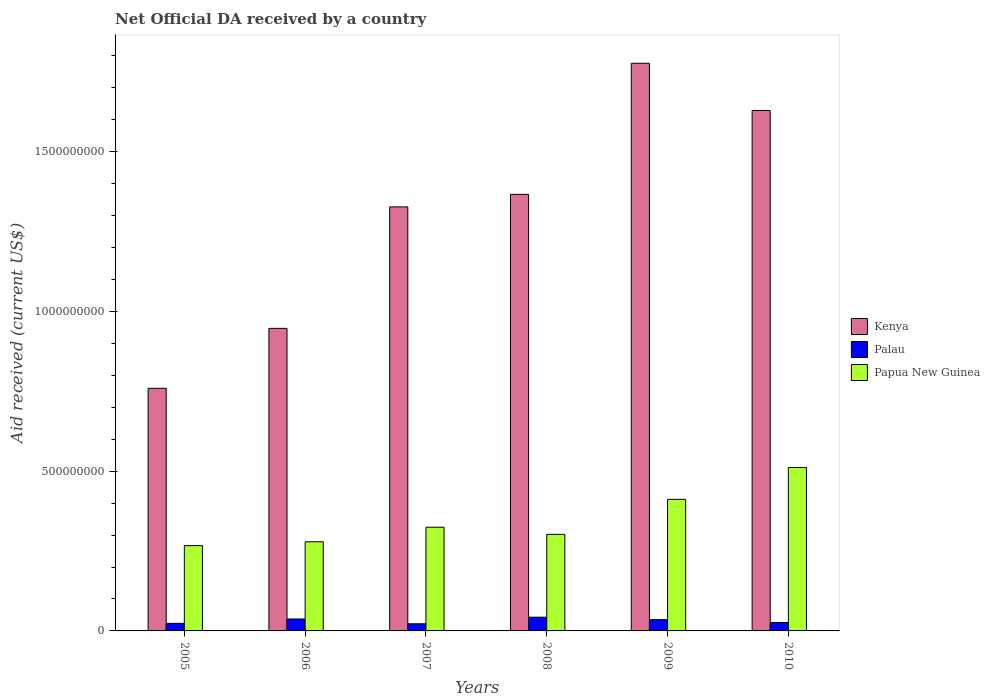How many groups of bars are there?
Provide a succinct answer. 6. Are the number of bars per tick equal to the number of legend labels?
Offer a very short reply. Yes. Are the number of bars on each tick of the X-axis equal?
Make the answer very short. Yes. How many bars are there on the 1st tick from the left?
Keep it short and to the point. 3. What is the net official development assistance aid received in Kenya in 2006?
Ensure brevity in your answer.  9.47e+08. Across all years, what is the maximum net official development assistance aid received in Kenya?
Offer a very short reply. 1.78e+09. Across all years, what is the minimum net official development assistance aid received in Papua New Guinea?
Provide a short and direct response. 2.67e+08. In which year was the net official development assistance aid received in Palau maximum?
Provide a short and direct response. 2008. What is the total net official development assistance aid received in Papua New Guinea in the graph?
Your response must be concise. 2.10e+09. What is the difference between the net official development assistance aid received in Palau in 2005 and that in 2009?
Provide a short and direct response. -1.17e+07. What is the difference between the net official development assistance aid received in Kenya in 2008 and the net official development assistance aid received in Papua New Guinea in 2005?
Provide a short and direct response. 1.10e+09. What is the average net official development assistance aid received in Palau per year?
Keep it short and to the point. 3.13e+07. In the year 2007, what is the difference between the net official development assistance aid received in Kenya and net official development assistance aid received in Palau?
Your answer should be very brief. 1.30e+09. What is the ratio of the net official development assistance aid received in Papua New Guinea in 2007 to that in 2010?
Your answer should be compact. 0.63. Is the net official development assistance aid received in Palau in 2007 less than that in 2010?
Provide a succinct answer. Yes. What is the difference between the highest and the second highest net official development assistance aid received in Palau?
Your answer should be very brief. 5.62e+06. What is the difference between the highest and the lowest net official development assistance aid received in Kenya?
Ensure brevity in your answer.  1.02e+09. In how many years, is the net official development assistance aid received in Kenya greater than the average net official development assistance aid received in Kenya taken over all years?
Ensure brevity in your answer.  4. What does the 2nd bar from the left in 2009 represents?
Ensure brevity in your answer.  Palau. What does the 3rd bar from the right in 2005 represents?
Offer a very short reply. Kenya. Is it the case that in every year, the sum of the net official development assistance aid received in Palau and net official development assistance aid received in Papua New Guinea is greater than the net official development assistance aid received in Kenya?
Your response must be concise. No. How many years are there in the graph?
Offer a terse response. 6. What is the difference between two consecutive major ticks on the Y-axis?
Your response must be concise. 5.00e+08. Are the values on the major ticks of Y-axis written in scientific E-notation?
Make the answer very short. No. Does the graph contain any zero values?
Your answer should be compact. No. Does the graph contain grids?
Offer a terse response. No. Where does the legend appear in the graph?
Offer a very short reply. Center right. How many legend labels are there?
Offer a terse response. 3. What is the title of the graph?
Provide a succinct answer. Net Official DA received by a country. What is the label or title of the X-axis?
Your response must be concise. Years. What is the label or title of the Y-axis?
Make the answer very short. Aid received (current US$). What is the Aid received (current US$) in Kenya in 2005?
Provide a succinct answer. 7.59e+08. What is the Aid received (current US$) of Palau in 2005?
Offer a terse response. 2.37e+07. What is the Aid received (current US$) in Papua New Guinea in 2005?
Offer a terse response. 2.67e+08. What is the Aid received (current US$) in Kenya in 2006?
Your answer should be compact. 9.47e+08. What is the Aid received (current US$) of Palau in 2006?
Ensure brevity in your answer.  3.73e+07. What is the Aid received (current US$) of Papua New Guinea in 2006?
Ensure brevity in your answer.  2.79e+08. What is the Aid received (current US$) in Kenya in 2007?
Make the answer very short. 1.33e+09. What is the Aid received (current US$) of Palau in 2007?
Your answer should be very brief. 2.23e+07. What is the Aid received (current US$) of Papua New Guinea in 2007?
Your answer should be compact. 3.24e+08. What is the Aid received (current US$) in Kenya in 2008?
Ensure brevity in your answer.  1.37e+09. What is the Aid received (current US$) in Palau in 2008?
Your answer should be very brief. 4.29e+07. What is the Aid received (current US$) of Papua New Guinea in 2008?
Your response must be concise. 3.02e+08. What is the Aid received (current US$) of Kenya in 2009?
Make the answer very short. 1.78e+09. What is the Aid received (current US$) in Palau in 2009?
Your answer should be compact. 3.54e+07. What is the Aid received (current US$) in Papua New Guinea in 2009?
Keep it short and to the point. 4.12e+08. What is the Aid received (current US$) of Kenya in 2010?
Your answer should be compact. 1.63e+09. What is the Aid received (current US$) in Palau in 2010?
Offer a very short reply. 2.63e+07. What is the Aid received (current US$) in Papua New Guinea in 2010?
Offer a very short reply. 5.11e+08. Across all years, what is the maximum Aid received (current US$) of Kenya?
Give a very brief answer. 1.78e+09. Across all years, what is the maximum Aid received (current US$) of Palau?
Give a very brief answer. 4.29e+07. Across all years, what is the maximum Aid received (current US$) of Papua New Guinea?
Keep it short and to the point. 5.11e+08. Across all years, what is the minimum Aid received (current US$) in Kenya?
Your response must be concise. 7.59e+08. Across all years, what is the minimum Aid received (current US$) in Palau?
Your response must be concise. 2.23e+07. Across all years, what is the minimum Aid received (current US$) in Papua New Guinea?
Provide a succinct answer. 2.67e+08. What is the total Aid received (current US$) in Kenya in the graph?
Offer a very short reply. 7.80e+09. What is the total Aid received (current US$) of Palau in the graph?
Ensure brevity in your answer.  1.88e+08. What is the total Aid received (current US$) in Papua New Guinea in the graph?
Give a very brief answer. 2.10e+09. What is the difference between the Aid received (current US$) in Kenya in 2005 and that in 2006?
Provide a succinct answer. -1.88e+08. What is the difference between the Aid received (current US$) of Palau in 2005 and that in 2006?
Give a very brief answer. -1.36e+07. What is the difference between the Aid received (current US$) in Papua New Guinea in 2005 and that in 2006?
Your answer should be very brief. -1.20e+07. What is the difference between the Aid received (current US$) in Kenya in 2005 and that in 2007?
Offer a very short reply. -5.68e+08. What is the difference between the Aid received (current US$) of Palau in 2005 and that in 2007?
Provide a short and direct response. 1.35e+06. What is the difference between the Aid received (current US$) in Papua New Guinea in 2005 and that in 2007?
Give a very brief answer. -5.75e+07. What is the difference between the Aid received (current US$) of Kenya in 2005 and that in 2008?
Offer a terse response. -6.07e+08. What is the difference between the Aid received (current US$) of Palau in 2005 and that in 2008?
Your answer should be very brief. -1.92e+07. What is the difference between the Aid received (current US$) of Papua New Guinea in 2005 and that in 2008?
Make the answer very short. -3.52e+07. What is the difference between the Aid received (current US$) in Kenya in 2005 and that in 2009?
Keep it short and to the point. -1.02e+09. What is the difference between the Aid received (current US$) of Palau in 2005 and that in 2009?
Offer a very short reply. -1.17e+07. What is the difference between the Aid received (current US$) in Papua New Guinea in 2005 and that in 2009?
Provide a short and direct response. -1.45e+08. What is the difference between the Aid received (current US$) in Kenya in 2005 and that in 2010?
Offer a terse response. -8.69e+08. What is the difference between the Aid received (current US$) in Palau in 2005 and that in 2010?
Your response must be concise. -2.62e+06. What is the difference between the Aid received (current US$) of Papua New Guinea in 2005 and that in 2010?
Your response must be concise. -2.44e+08. What is the difference between the Aid received (current US$) in Kenya in 2006 and that in 2007?
Ensure brevity in your answer.  -3.80e+08. What is the difference between the Aid received (current US$) in Palau in 2006 and that in 2007?
Offer a very short reply. 1.50e+07. What is the difference between the Aid received (current US$) of Papua New Guinea in 2006 and that in 2007?
Give a very brief answer. -4.56e+07. What is the difference between the Aid received (current US$) of Kenya in 2006 and that in 2008?
Your answer should be very brief. -4.19e+08. What is the difference between the Aid received (current US$) in Palau in 2006 and that in 2008?
Your answer should be very brief. -5.62e+06. What is the difference between the Aid received (current US$) in Papua New Guinea in 2006 and that in 2008?
Keep it short and to the point. -2.32e+07. What is the difference between the Aid received (current US$) in Kenya in 2006 and that in 2009?
Your answer should be compact. -8.30e+08. What is the difference between the Aid received (current US$) of Palau in 2006 and that in 2009?
Provide a short and direct response. 1.97e+06. What is the difference between the Aid received (current US$) in Papua New Guinea in 2006 and that in 2009?
Ensure brevity in your answer.  -1.33e+08. What is the difference between the Aid received (current US$) in Kenya in 2006 and that in 2010?
Provide a succinct answer. -6.82e+08. What is the difference between the Aid received (current US$) of Palau in 2006 and that in 2010?
Your answer should be very brief. 1.10e+07. What is the difference between the Aid received (current US$) of Papua New Guinea in 2006 and that in 2010?
Give a very brief answer. -2.33e+08. What is the difference between the Aid received (current US$) of Kenya in 2007 and that in 2008?
Your answer should be very brief. -3.92e+07. What is the difference between the Aid received (current US$) in Palau in 2007 and that in 2008?
Offer a very short reply. -2.06e+07. What is the difference between the Aid received (current US$) in Papua New Guinea in 2007 and that in 2008?
Make the answer very short. 2.23e+07. What is the difference between the Aid received (current US$) in Kenya in 2007 and that in 2009?
Your response must be concise. -4.49e+08. What is the difference between the Aid received (current US$) of Palau in 2007 and that in 2009?
Your response must be concise. -1.30e+07. What is the difference between the Aid received (current US$) in Papua New Guinea in 2007 and that in 2009?
Your answer should be very brief. -8.72e+07. What is the difference between the Aid received (current US$) in Kenya in 2007 and that in 2010?
Provide a succinct answer. -3.02e+08. What is the difference between the Aid received (current US$) in Palau in 2007 and that in 2010?
Offer a very short reply. -3.97e+06. What is the difference between the Aid received (current US$) in Papua New Guinea in 2007 and that in 2010?
Provide a short and direct response. -1.87e+08. What is the difference between the Aid received (current US$) of Kenya in 2008 and that in 2009?
Your response must be concise. -4.10e+08. What is the difference between the Aid received (current US$) of Palau in 2008 and that in 2009?
Provide a succinct answer. 7.59e+06. What is the difference between the Aid received (current US$) of Papua New Guinea in 2008 and that in 2009?
Ensure brevity in your answer.  -1.10e+08. What is the difference between the Aid received (current US$) in Kenya in 2008 and that in 2010?
Make the answer very short. -2.63e+08. What is the difference between the Aid received (current US$) in Palau in 2008 and that in 2010?
Give a very brief answer. 1.66e+07. What is the difference between the Aid received (current US$) of Papua New Guinea in 2008 and that in 2010?
Keep it short and to the point. -2.09e+08. What is the difference between the Aid received (current US$) of Kenya in 2009 and that in 2010?
Your answer should be compact. 1.48e+08. What is the difference between the Aid received (current US$) in Palau in 2009 and that in 2010?
Give a very brief answer. 9.04e+06. What is the difference between the Aid received (current US$) in Papua New Guinea in 2009 and that in 2010?
Make the answer very short. -9.97e+07. What is the difference between the Aid received (current US$) of Kenya in 2005 and the Aid received (current US$) of Palau in 2006?
Offer a terse response. 7.22e+08. What is the difference between the Aid received (current US$) in Kenya in 2005 and the Aid received (current US$) in Papua New Guinea in 2006?
Ensure brevity in your answer.  4.80e+08. What is the difference between the Aid received (current US$) in Palau in 2005 and the Aid received (current US$) in Papua New Guinea in 2006?
Make the answer very short. -2.55e+08. What is the difference between the Aid received (current US$) of Kenya in 2005 and the Aid received (current US$) of Palau in 2007?
Make the answer very short. 7.37e+08. What is the difference between the Aid received (current US$) of Kenya in 2005 and the Aid received (current US$) of Papua New Guinea in 2007?
Your answer should be compact. 4.35e+08. What is the difference between the Aid received (current US$) of Palau in 2005 and the Aid received (current US$) of Papua New Guinea in 2007?
Ensure brevity in your answer.  -3.01e+08. What is the difference between the Aid received (current US$) of Kenya in 2005 and the Aid received (current US$) of Palau in 2008?
Provide a short and direct response. 7.16e+08. What is the difference between the Aid received (current US$) of Kenya in 2005 and the Aid received (current US$) of Papua New Guinea in 2008?
Provide a short and direct response. 4.57e+08. What is the difference between the Aid received (current US$) of Palau in 2005 and the Aid received (current US$) of Papua New Guinea in 2008?
Keep it short and to the point. -2.78e+08. What is the difference between the Aid received (current US$) of Kenya in 2005 and the Aid received (current US$) of Palau in 2009?
Provide a succinct answer. 7.24e+08. What is the difference between the Aid received (current US$) in Kenya in 2005 and the Aid received (current US$) in Papua New Guinea in 2009?
Offer a terse response. 3.48e+08. What is the difference between the Aid received (current US$) of Palau in 2005 and the Aid received (current US$) of Papua New Guinea in 2009?
Your answer should be compact. -3.88e+08. What is the difference between the Aid received (current US$) of Kenya in 2005 and the Aid received (current US$) of Palau in 2010?
Give a very brief answer. 7.33e+08. What is the difference between the Aid received (current US$) of Kenya in 2005 and the Aid received (current US$) of Papua New Guinea in 2010?
Keep it short and to the point. 2.48e+08. What is the difference between the Aid received (current US$) of Palau in 2005 and the Aid received (current US$) of Papua New Guinea in 2010?
Make the answer very short. -4.88e+08. What is the difference between the Aid received (current US$) in Kenya in 2006 and the Aid received (current US$) in Palau in 2007?
Your answer should be very brief. 9.24e+08. What is the difference between the Aid received (current US$) in Kenya in 2006 and the Aid received (current US$) in Papua New Guinea in 2007?
Make the answer very short. 6.22e+08. What is the difference between the Aid received (current US$) of Palau in 2006 and the Aid received (current US$) of Papua New Guinea in 2007?
Keep it short and to the point. -2.87e+08. What is the difference between the Aid received (current US$) in Kenya in 2006 and the Aid received (current US$) in Palau in 2008?
Make the answer very short. 9.04e+08. What is the difference between the Aid received (current US$) in Kenya in 2006 and the Aid received (current US$) in Papua New Guinea in 2008?
Your answer should be compact. 6.45e+08. What is the difference between the Aid received (current US$) in Palau in 2006 and the Aid received (current US$) in Papua New Guinea in 2008?
Offer a very short reply. -2.65e+08. What is the difference between the Aid received (current US$) of Kenya in 2006 and the Aid received (current US$) of Palau in 2009?
Provide a succinct answer. 9.11e+08. What is the difference between the Aid received (current US$) in Kenya in 2006 and the Aid received (current US$) in Papua New Guinea in 2009?
Your response must be concise. 5.35e+08. What is the difference between the Aid received (current US$) in Palau in 2006 and the Aid received (current US$) in Papua New Guinea in 2009?
Your answer should be compact. -3.74e+08. What is the difference between the Aid received (current US$) in Kenya in 2006 and the Aid received (current US$) in Palau in 2010?
Offer a very short reply. 9.20e+08. What is the difference between the Aid received (current US$) in Kenya in 2006 and the Aid received (current US$) in Papua New Guinea in 2010?
Give a very brief answer. 4.35e+08. What is the difference between the Aid received (current US$) in Palau in 2006 and the Aid received (current US$) in Papua New Guinea in 2010?
Offer a terse response. -4.74e+08. What is the difference between the Aid received (current US$) of Kenya in 2007 and the Aid received (current US$) of Palau in 2008?
Offer a very short reply. 1.28e+09. What is the difference between the Aid received (current US$) in Kenya in 2007 and the Aid received (current US$) in Papua New Guinea in 2008?
Give a very brief answer. 1.02e+09. What is the difference between the Aid received (current US$) of Palau in 2007 and the Aid received (current US$) of Papua New Guinea in 2008?
Offer a terse response. -2.80e+08. What is the difference between the Aid received (current US$) in Kenya in 2007 and the Aid received (current US$) in Palau in 2009?
Make the answer very short. 1.29e+09. What is the difference between the Aid received (current US$) in Kenya in 2007 and the Aid received (current US$) in Papua New Guinea in 2009?
Your answer should be compact. 9.15e+08. What is the difference between the Aid received (current US$) in Palau in 2007 and the Aid received (current US$) in Papua New Guinea in 2009?
Your response must be concise. -3.89e+08. What is the difference between the Aid received (current US$) in Kenya in 2007 and the Aid received (current US$) in Palau in 2010?
Your answer should be very brief. 1.30e+09. What is the difference between the Aid received (current US$) in Kenya in 2007 and the Aid received (current US$) in Papua New Guinea in 2010?
Your response must be concise. 8.15e+08. What is the difference between the Aid received (current US$) in Palau in 2007 and the Aid received (current US$) in Papua New Guinea in 2010?
Offer a terse response. -4.89e+08. What is the difference between the Aid received (current US$) of Kenya in 2008 and the Aid received (current US$) of Palau in 2009?
Your response must be concise. 1.33e+09. What is the difference between the Aid received (current US$) in Kenya in 2008 and the Aid received (current US$) in Papua New Guinea in 2009?
Your answer should be very brief. 9.54e+08. What is the difference between the Aid received (current US$) of Palau in 2008 and the Aid received (current US$) of Papua New Guinea in 2009?
Provide a succinct answer. -3.69e+08. What is the difference between the Aid received (current US$) of Kenya in 2008 and the Aid received (current US$) of Palau in 2010?
Provide a succinct answer. 1.34e+09. What is the difference between the Aid received (current US$) in Kenya in 2008 and the Aid received (current US$) in Papua New Guinea in 2010?
Ensure brevity in your answer.  8.55e+08. What is the difference between the Aid received (current US$) in Palau in 2008 and the Aid received (current US$) in Papua New Guinea in 2010?
Ensure brevity in your answer.  -4.68e+08. What is the difference between the Aid received (current US$) in Kenya in 2009 and the Aid received (current US$) in Palau in 2010?
Your response must be concise. 1.75e+09. What is the difference between the Aid received (current US$) in Kenya in 2009 and the Aid received (current US$) in Papua New Guinea in 2010?
Offer a very short reply. 1.26e+09. What is the difference between the Aid received (current US$) in Palau in 2009 and the Aid received (current US$) in Papua New Guinea in 2010?
Offer a very short reply. -4.76e+08. What is the average Aid received (current US$) in Kenya per year?
Provide a succinct answer. 1.30e+09. What is the average Aid received (current US$) of Palau per year?
Keep it short and to the point. 3.13e+07. What is the average Aid received (current US$) in Papua New Guinea per year?
Offer a very short reply. 3.49e+08. In the year 2005, what is the difference between the Aid received (current US$) in Kenya and Aid received (current US$) in Palau?
Keep it short and to the point. 7.36e+08. In the year 2005, what is the difference between the Aid received (current US$) of Kenya and Aid received (current US$) of Papua New Guinea?
Ensure brevity in your answer.  4.92e+08. In the year 2005, what is the difference between the Aid received (current US$) in Palau and Aid received (current US$) in Papua New Guinea?
Your answer should be compact. -2.43e+08. In the year 2006, what is the difference between the Aid received (current US$) in Kenya and Aid received (current US$) in Palau?
Give a very brief answer. 9.09e+08. In the year 2006, what is the difference between the Aid received (current US$) in Kenya and Aid received (current US$) in Papua New Guinea?
Provide a short and direct response. 6.68e+08. In the year 2006, what is the difference between the Aid received (current US$) of Palau and Aid received (current US$) of Papua New Guinea?
Give a very brief answer. -2.42e+08. In the year 2007, what is the difference between the Aid received (current US$) in Kenya and Aid received (current US$) in Palau?
Give a very brief answer. 1.30e+09. In the year 2007, what is the difference between the Aid received (current US$) in Kenya and Aid received (current US$) in Papua New Guinea?
Offer a very short reply. 1.00e+09. In the year 2007, what is the difference between the Aid received (current US$) in Palau and Aid received (current US$) in Papua New Guinea?
Give a very brief answer. -3.02e+08. In the year 2008, what is the difference between the Aid received (current US$) in Kenya and Aid received (current US$) in Palau?
Offer a very short reply. 1.32e+09. In the year 2008, what is the difference between the Aid received (current US$) of Kenya and Aid received (current US$) of Papua New Guinea?
Keep it short and to the point. 1.06e+09. In the year 2008, what is the difference between the Aid received (current US$) of Palau and Aid received (current US$) of Papua New Guinea?
Make the answer very short. -2.59e+08. In the year 2009, what is the difference between the Aid received (current US$) in Kenya and Aid received (current US$) in Palau?
Offer a terse response. 1.74e+09. In the year 2009, what is the difference between the Aid received (current US$) in Kenya and Aid received (current US$) in Papua New Guinea?
Keep it short and to the point. 1.36e+09. In the year 2009, what is the difference between the Aid received (current US$) of Palau and Aid received (current US$) of Papua New Guinea?
Offer a very short reply. -3.76e+08. In the year 2010, what is the difference between the Aid received (current US$) in Kenya and Aid received (current US$) in Palau?
Give a very brief answer. 1.60e+09. In the year 2010, what is the difference between the Aid received (current US$) in Kenya and Aid received (current US$) in Papua New Guinea?
Your answer should be very brief. 1.12e+09. In the year 2010, what is the difference between the Aid received (current US$) of Palau and Aid received (current US$) of Papua New Guinea?
Your answer should be compact. -4.85e+08. What is the ratio of the Aid received (current US$) of Kenya in 2005 to that in 2006?
Provide a short and direct response. 0.8. What is the ratio of the Aid received (current US$) in Palau in 2005 to that in 2006?
Keep it short and to the point. 0.63. What is the ratio of the Aid received (current US$) of Papua New Guinea in 2005 to that in 2006?
Make the answer very short. 0.96. What is the ratio of the Aid received (current US$) in Kenya in 2005 to that in 2007?
Ensure brevity in your answer.  0.57. What is the ratio of the Aid received (current US$) of Palau in 2005 to that in 2007?
Make the answer very short. 1.06. What is the ratio of the Aid received (current US$) of Papua New Guinea in 2005 to that in 2007?
Give a very brief answer. 0.82. What is the ratio of the Aid received (current US$) in Kenya in 2005 to that in 2008?
Keep it short and to the point. 0.56. What is the ratio of the Aid received (current US$) in Palau in 2005 to that in 2008?
Your answer should be compact. 0.55. What is the ratio of the Aid received (current US$) in Papua New Guinea in 2005 to that in 2008?
Provide a succinct answer. 0.88. What is the ratio of the Aid received (current US$) in Kenya in 2005 to that in 2009?
Your answer should be very brief. 0.43. What is the ratio of the Aid received (current US$) of Palau in 2005 to that in 2009?
Your answer should be compact. 0.67. What is the ratio of the Aid received (current US$) of Papua New Guinea in 2005 to that in 2009?
Provide a succinct answer. 0.65. What is the ratio of the Aid received (current US$) of Kenya in 2005 to that in 2010?
Your answer should be compact. 0.47. What is the ratio of the Aid received (current US$) in Palau in 2005 to that in 2010?
Keep it short and to the point. 0.9. What is the ratio of the Aid received (current US$) of Papua New Guinea in 2005 to that in 2010?
Make the answer very short. 0.52. What is the ratio of the Aid received (current US$) in Kenya in 2006 to that in 2007?
Provide a short and direct response. 0.71. What is the ratio of the Aid received (current US$) of Palau in 2006 to that in 2007?
Provide a succinct answer. 1.67. What is the ratio of the Aid received (current US$) of Papua New Guinea in 2006 to that in 2007?
Your answer should be compact. 0.86. What is the ratio of the Aid received (current US$) of Kenya in 2006 to that in 2008?
Make the answer very short. 0.69. What is the ratio of the Aid received (current US$) of Palau in 2006 to that in 2008?
Ensure brevity in your answer.  0.87. What is the ratio of the Aid received (current US$) in Papua New Guinea in 2006 to that in 2008?
Make the answer very short. 0.92. What is the ratio of the Aid received (current US$) in Kenya in 2006 to that in 2009?
Give a very brief answer. 0.53. What is the ratio of the Aid received (current US$) of Palau in 2006 to that in 2009?
Give a very brief answer. 1.06. What is the ratio of the Aid received (current US$) of Papua New Guinea in 2006 to that in 2009?
Make the answer very short. 0.68. What is the ratio of the Aid received (current US$) in Kenya in 2006 to that in 2010?
Make the answer very short. 0.58. What is the ratio of the Aid received (current US$) in Palau in 2006 to that in 2010?
Provide a succinct answer. 1.42. What is the ratio of the Aid received (current US$) of Papua New Guinea in 2006 to that in 2010?
Ensure brevity in your answer.  0.55. What is the ratio of the Aid received (current US$) of Kenya in 2007 to that in 2008?
Offer a terse response. 0.97. What is the ratio of the Aid received (current US$) in Palau in 2007 to that in 2008?
Your answer should be compact. 0.52. What is the ratio of the Aid received (current US$) in Papua New Guinea in 2007 to that in 2008?
Provide a succinct answer. 1.07. What is the ratio of the Aid received (current US$) of Kenya in 2007 to that in 2009?
Provide a succinct answer. 0.75. What is the ratio of the Aid received (current US$) of Palau in 2007 to that in 2009?
Keep it short and to the point. 0.63. What is the ratio of the Aid received (current US$) in Papua New Guinea in 2007 to that in 2009?
Make the answer very short. 0.79. What is the ratio of the Aid received (current US$) of Kenya in 2007 to that in 2010?
Make the answer very short. 0.81. What is the ratio of the Aid received (current US$) in Palau in 2007 to that in 2010?
Your answer should be very brief. 0.85. What is the ratio of the Aid received (current US$) of Papua New Guinea in 2007 to that in 2010?
Ensure brevity in your answer.  0.63. What is the ratio of the Aid received (current US$) of Kenya in 2008 to that in 2009?
Offer a terse response. 0.77. What is the ratio of the Aid received (current US$) in Palau in 2008 to that in 2009?
Ensure brevity in your answer.  1.21. What is the ratio of the Aid received (current US$) in Papua New Guinea in 2008 to that in 2009?
Make the answer very short. 0.73. What is the ratio of the Aid received (current US$) in Kenya in 2008 to that in 2010?
Provide a succinct answer. 0.84. What is the ratio of the Aid received (current US$) in Palau in 2008 to that in 2010?
Your answer should be very brief. 1.63. What is the ratio of the Aid received (current US$) in Papua New Guinea in 2008 to that in 2010?
Your response must be concise. 0.59. What is the ratio of the Aid received (current US$) of Kenya in 2009 to that in 2010?
Provide a succinct answer. 1.09. What is the ratio of the Aid received (current US$) in Palau in 2009 to that in 2010?
Provide a short and direct response. 1.34. What is the ratio of the Aid received (current US$) in Papua New Guinea in 2009 to that in 2010?
Keep it short and to the point. 0.81. What is the difference between the highest and the second highest Aid received (current US$) of Kenya?
Offer a terse response. 1.48e+08. What is the difference between the highest and the second highest Aid received (current US$) in Palau?
Provide a succinct answer. 5.62e+06. What is the difference between the highest and the second highest Aid received (current US$) of Papua New Guinea?
Offer a very short reply. 9.97e+07. What is the difference between the highest and the lowest Aid received (current US$) in Kenya?
Your response must be concise. 1.02e+09. What is the difference between the highest and the lowest Aid received (current US$) of Palau?
Your answer should be compact. 2.06e+07. What is the difference between the highest and the lowest Aid received (current US$) of Papua New Guinea?
Keep it short and to the point. 2.44e+08. 